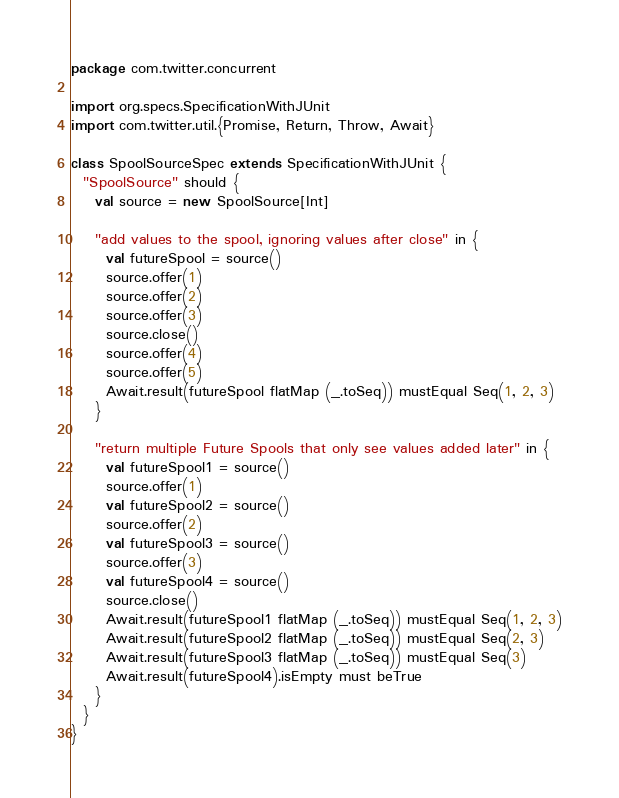<code> <loc_0><loc_0><loc_500><loc_500><_Scala_>package com.twitter.concurrent

import org.specs.SpecificationWithJUnit
import com.twitter.util.{Promise, Return, Throw, Await}

class SpoolSourceSpec extends SpecificationWithJUnit {
  "SpoolSource" should {
    val source = new SpoolSource[Int]

    "add values to the spool, ignoring values after close" in {
      val futureSpool = source()
      source.offer(1)
      source.offer(2)
      source.offer(3)
      source.close()
      source.offer(4)
      source.offer(5)
      Await.result(futureSpool flatMap (_.toSeq)) mustEqual Seq(1, 2, 3)
    }

    "return multiple Future Spools that only see values added later" in {
      val futureSpool1 = source()
      source.offer(1)
      val futureSpool2 = source()
      source.offer(2)
      val futureSpool3 = source()
      source.offer(3)
      val futureSpool4 = source()
      source.close()
      Await.result(futureSpool1 flatMap (_.toSeq)) mustEqual Seq(1, 2, 3)
      Await.result(futureSpool2 flatMap (_.toSeq)) mustEqual Seq(2, 3)
      Await.result(futureSpool3 flatMap (_.toSeq)) mustEqual Seq(3)
      Await.result(futureSpool4).isEmpty must beTrue
    }
  }
}
</code> 